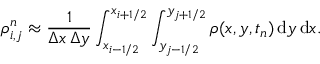<formula> <loc_0><loc_0><loc_500><loc_500>\rho _ { i , j } ^ { n } \approx \frac { 1 } { \Delta x \, \Delta y } \int _ { x _ { i - 1 / 2 } } ^ { x _ { i + 1 / 2 } } \int _ { y _ { j - 1 / 2 } } ^ { y _ { j + 1 / 2 } } \rho ( x , y , t _ { n } ) \, d y \, d x .</formula> 